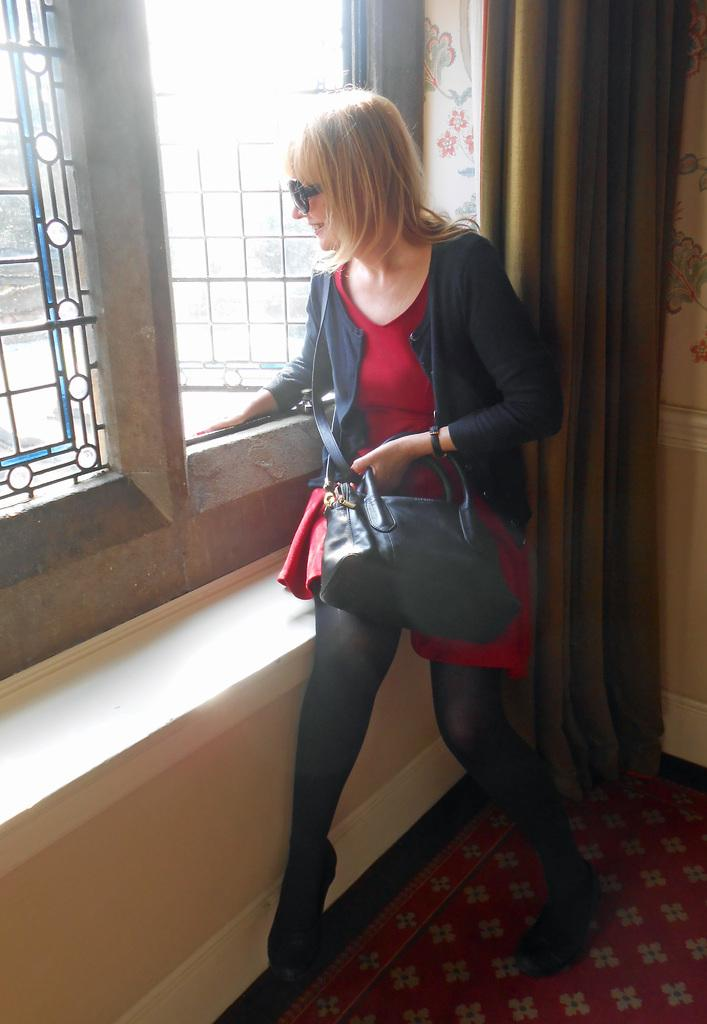Who is present in the image? There is a woman in the image. What is the woman holding in her hand? The woman is holding a bag in her hand. What type of protective eyewear does the woman have? The woman has goggles. What can be seen through the window in the image? The image does not show what can be seen through the window. What type of window treatment is present in the image? There is a curtain in the image. What surface is the woman standing on in the image? There is a floor in the image. What type of bean is the woman eating in the image? There is no bean present in the image, and the woman is not eating anything. 